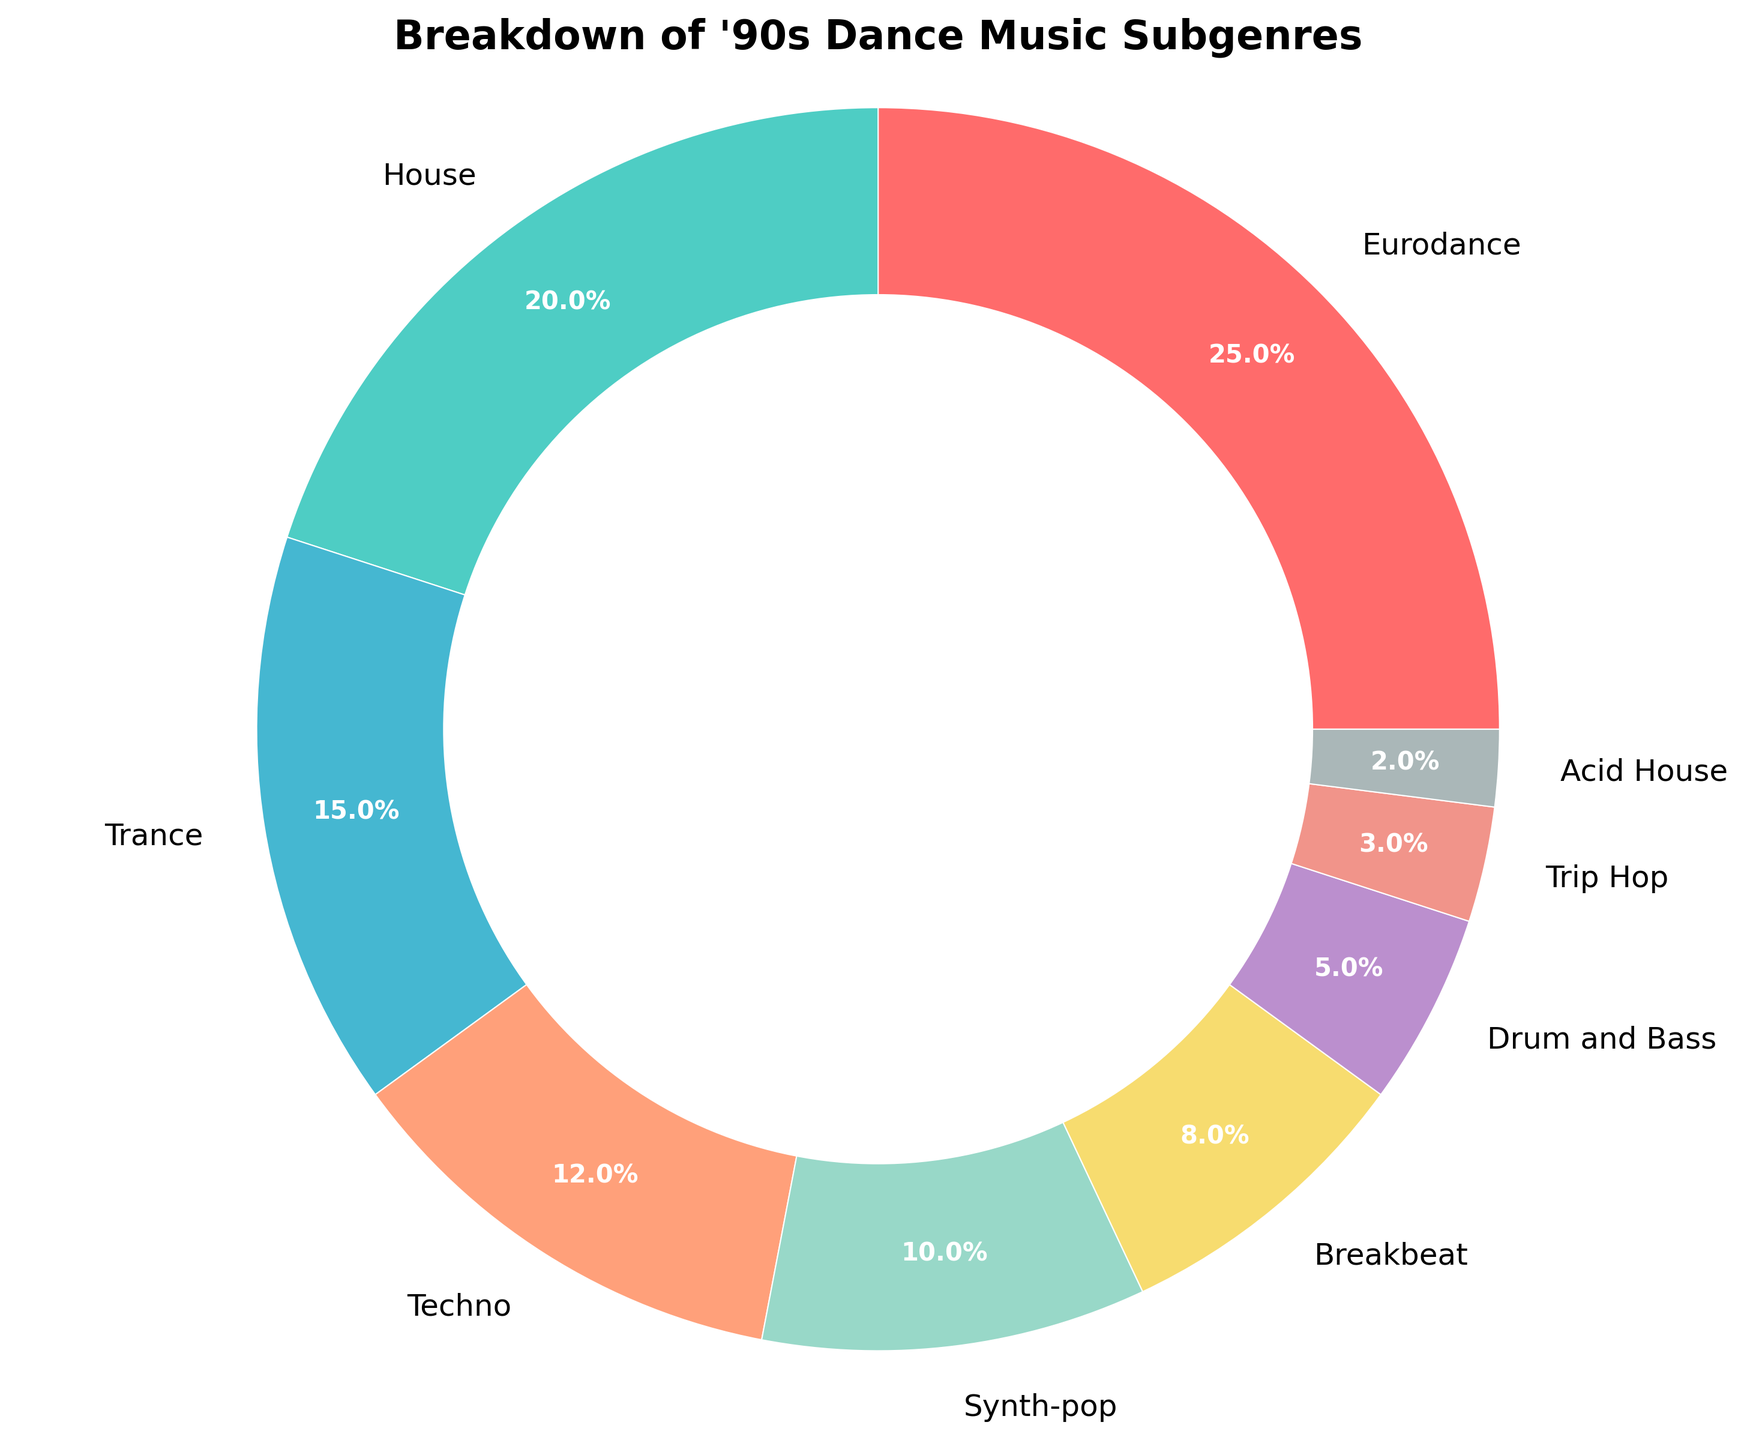What is the most represented '90s dance music subgenre? The genre with the largest percentage on the pie chart represents the most represented subgenre. According to the chart, Eurodance has the highest percentage.
Answer: Eurodance Which '90s dance music subgenre has the smallest representation? The subgenre with the smallest percentage on the pie chart has the smallest representation. Acid House has the lowest percentage on the chart.
Answer: Acid House How much more represented is House compared to Drum and Bass? To find out how much more represented House is compared to Drum and Bass, subtract the percentage of Drum and Bass from that of House. House is at 20% and Drum and Bass at 5%. So, 20% - 5% = 15%.
Answer: 15% Combine Synth-pop and Trip Hop, what percentage of the '90s dance music does it make up? Add the percentages of Synth-pop (10%) and Trip Hop (3%) to find the combined representation. Thus, 10% + 3% = 13%.
Answer: 13% Which genre is represented by the red color on the pie chart? By identifying the red color wedge on the pie chart, we can look at the label associated with the red wedge. The red color corresponds to Eurodance.
Answer: Eurodance Which two genres combined get closest to 50% representation? To find the combination closest to 50%, check different pairs of percentages: Eurodance (25%) + House (20%) = 45%, Eurodance (25%) + Trance (15%) = 40%, House (20%) + Trance (15%) = 35%, and so forth. Eurodance (25%) + House (20%) equals 45%, which is the closest to 50%.
Answer: Eurodance and House Compare the representation of Techno and Synth-pop. Which one has a higher percentage, and by how much? The percentages for Techno and Synth-pop are 12% and 10%, respectively. Subtract the smaller percentage from the larger one to find the difference. 12% - 10% = 2%.
Answer: Techno, 2% What is the combined representation of genres with less than 10% each? To find the combined representation, add the percentages of genres with less than 10% each: Synth-pop (10% is excluded), Breakbeat (8%), Drum and Bass (5%), Trip Hop (3%), and Acid House (2%). 8% + 5% + 3% + 2% = 18%.
Answer: 18% Which genre is represented by the green color? By looking at the green wedge on the pie chart, identify the label associated with that color. The green color corresponds to House.
Answer: House 